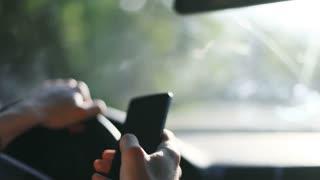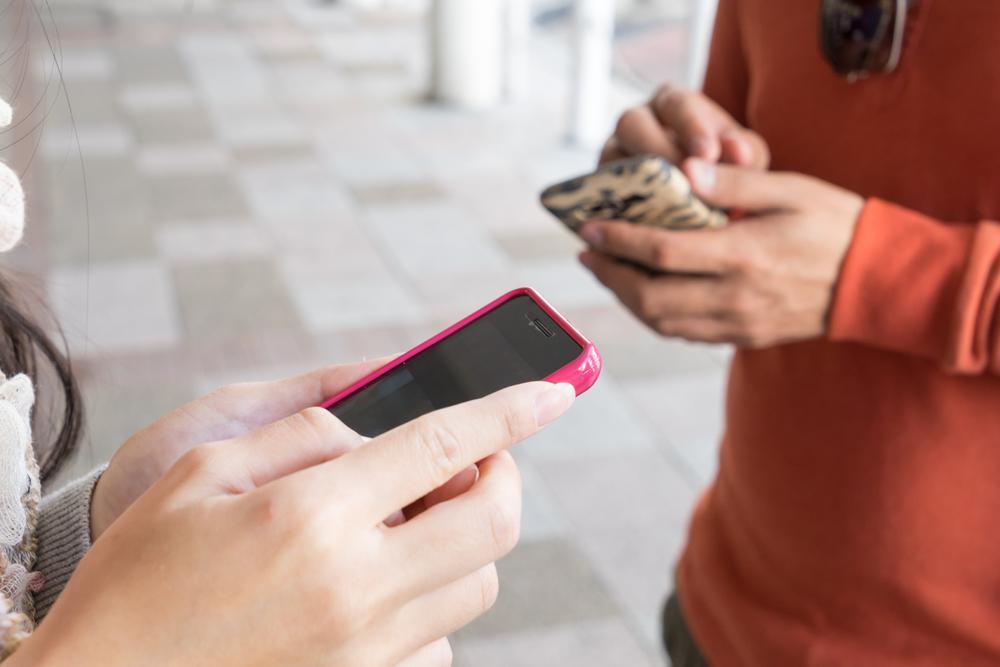The first image is the image on the left, the second image is the image on the right. For the images displayed, is the sentence "Exactly one phones is in contact with a single hand." factually correct? Answer yes or no. Yes. The first image is the image on the left, the second image is the image on the right. Examine the images to the left and right. Is the description "A single hand is holding a phone upright and head-on in one image, and the other image includes hands reaching in from opposite sides." accurate? Answer yes or no. No. 